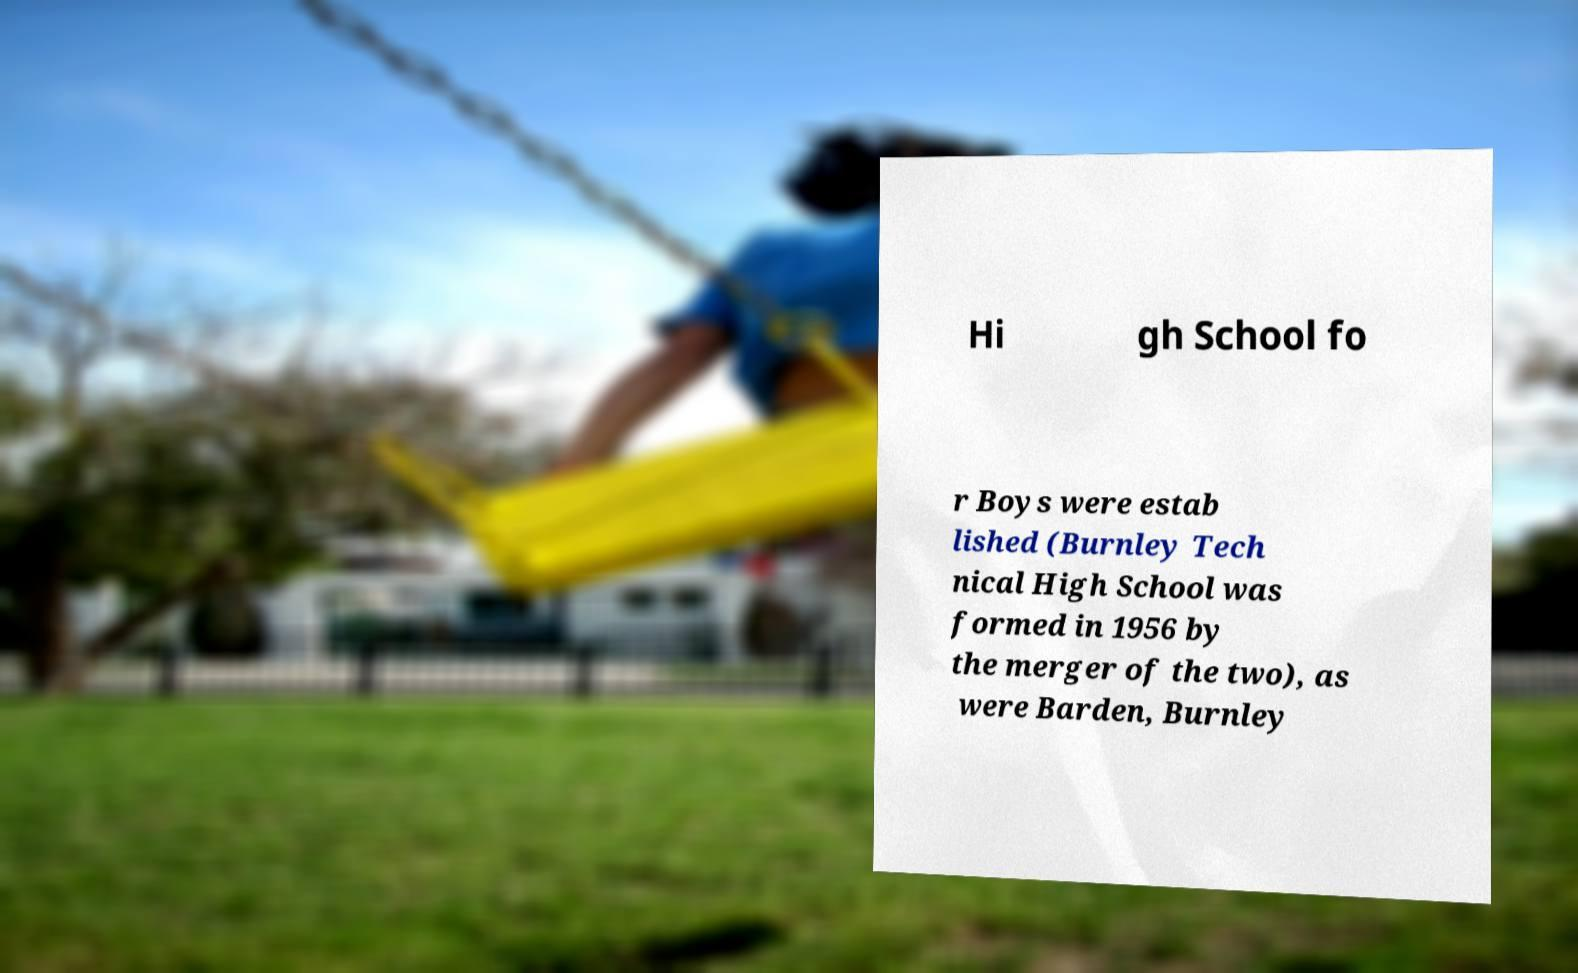Can you read and provide the text displayed in the image?This photo seems to have some interesting text. Can you extract and type it out for me? Hi gh School fo r Boys were estab lished (Burnley Tech nical High School was formed in 1956 by the merger of the two), as were Barden, Burnley 